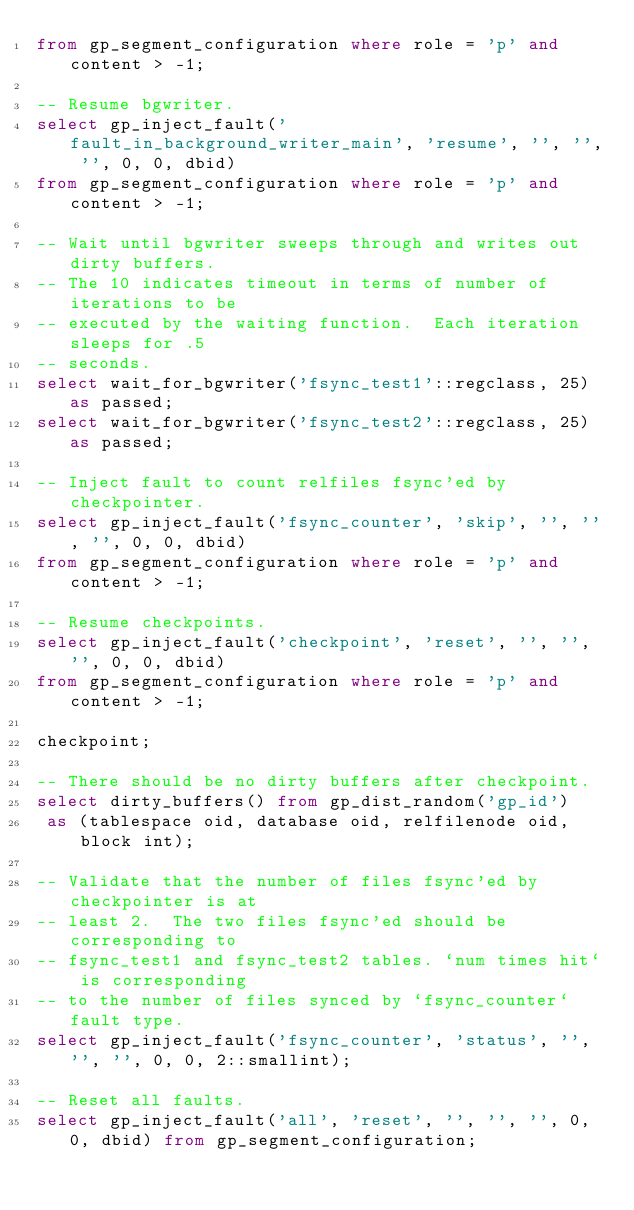Convert code to text. <code><loc_0><loc_0><loc_500><loc_500><_SQL_>from gp_segment_configuration where role = 'p' and content > -1;

-- Resume bgwriter.
select gp_inject_fault('fault_in_background_writer_main', 'resume', '', '', '', 0, 0, dbid)
from gp_segment_configuration where role = 'p' and content > -1;

-- Wait until bgwriter sweeps through and writes out dirty buffers.
-- The 10 indicates timeout in terms of number of iterations to be
-- executed by the waiting function.  Each iteration sleeps for .5
-- seconds.
select wait_for_bgwriter('fsync_test1'::regclass, 25) as passed;
select wait_for_bgwriter('fsync_test2'::regclass, 25) as passed;

-- Inject fault to count relfiles fsync'ed by checkpointer.
select gp_inject_fault('fsync_counter', 'skip', '', '', '', 0, 0, dbid)
from gp_segment_configuration where role = 'p' and content > -1;

-- Resume checkpoints.
select gp_inject_fault('checkpoint', 'reset', '', '', '', 0, 0, dbid)
from gp_segment_configuration where role = 'p' and content > -1;

checkpoint;

-- There should be no dirty buffers after checkpoint.
select dirty_buffers() from gp_dist_random('gp_id')
 as (tablespace oid, database oid, relfilenode oid, block int);

-- Validate that the number of files fsync'ed by checkpointer is at
-- least 2.  The two files fsync'ed should be corresponding to
-- fsync_test1 and fsync_test2 tables. `num times hit` is corresponding
-- to the number of files synced by `fsync_counter` fault type.
select gp_inject_fault('fsync_counter', 'status', '', '', '', 0, 0, 2::smallint);

-- Reset all faults.
select gp_inject_fault('all', 'reset', '', '', '', 0, 0, dbid) from gp_segment_configuration;
</code> 